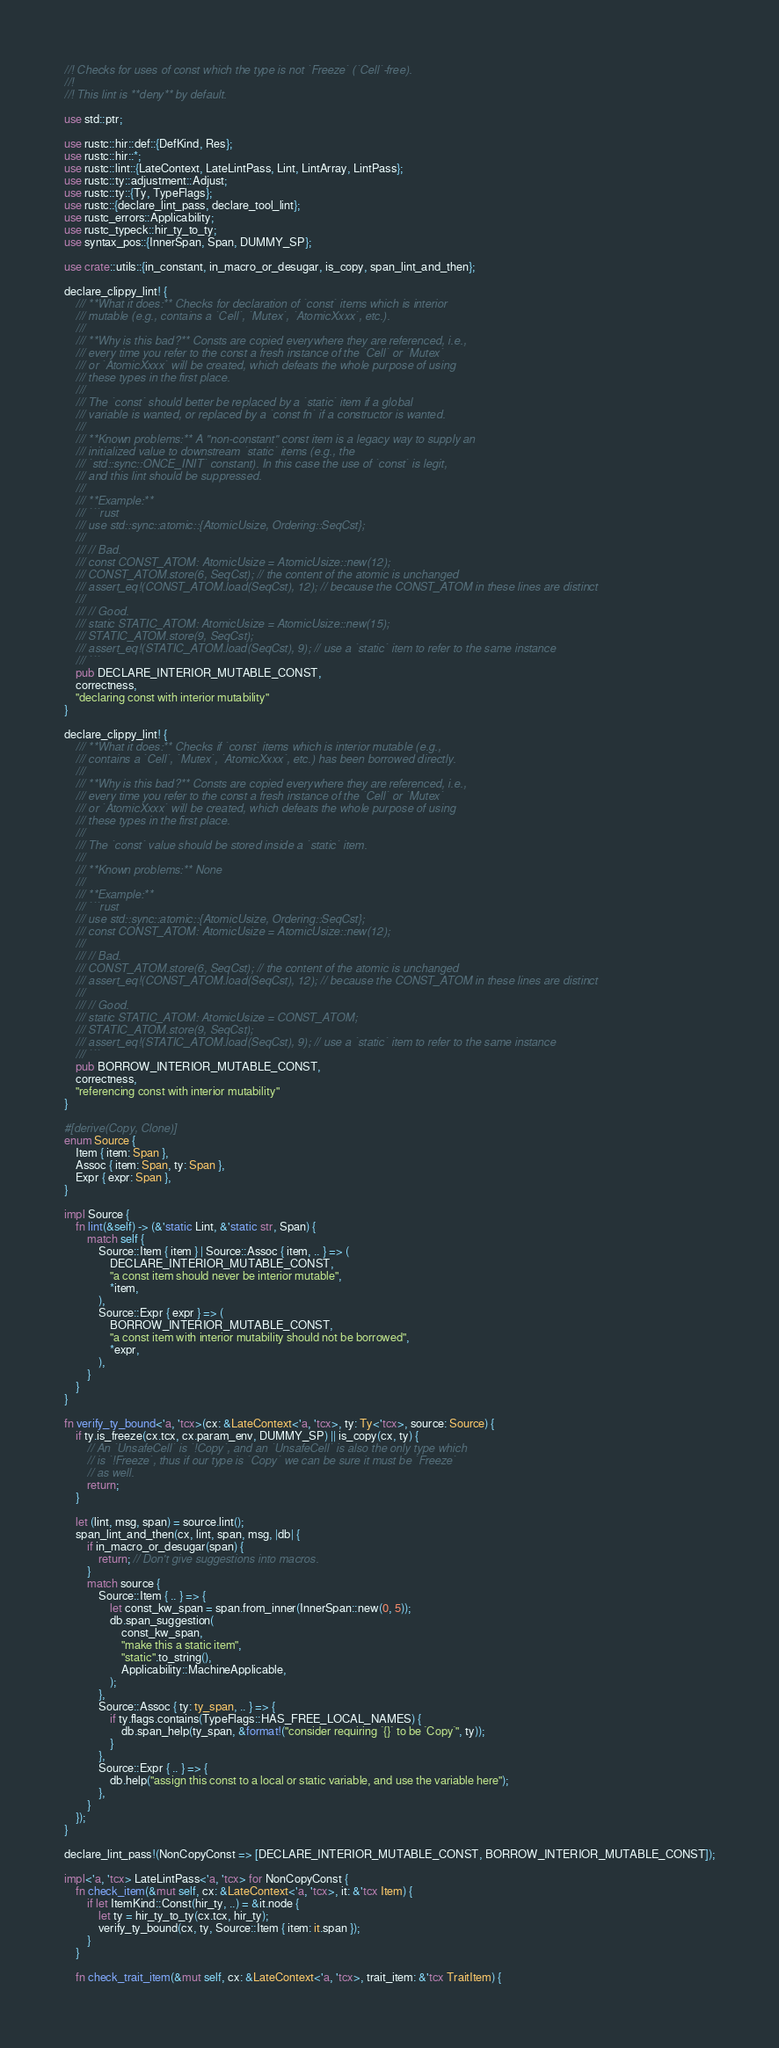Convert code to text. <code><loc_0><loc_0><loc_500><loc_500><_Rust_>//! Checks for uses of const which the type is not `Freeze` (`Cell`-free).
//!
//! This lint is **deny** by default.

use std::ptr;

use rustc::hir::def::{DefKind, Res};
use rustc::hir::*;
use rustc::lint::{LateContext, LateLintPass, Lint, LintArray, LintPass};
use rustc::ty::adjustment::Adjust;
use rustc::ty::{Ty, TypeFlags};
use rustc::{declare_lint_pass, declare_tool_lint};
use rustc_errors::Applicability;
use rustc_typeck::hir_ty_to_ty;
use syntax_pos::{InnerSpan, Span, DUMMY_SP};

use crate::utils::{in_constant, in_macro_or_desugar, is_copy, span_lint_and_then};

declare_clippy_lint! {
    /// **What it does:** Checks for declaration of `const` items which is interior
    /// mutable (e.g., contains a `Cell`, `Mutex`, `AtomicXxxx`, etc.).
    ///
    /// **Why is this bad?** Consts are copied everywhere they are referenced, i.e.,
    /// every time you refer to the const a fresh instance of the `Cell` or `Mutex`
    /// or `AtomicXxxx` will be created, which defeats the whole purpose of using
    /// these types in the first place.
    ///
    /// The `const` should better be replaced by a `static` item if a global
    /// variable is wanted, or replaced by a `const fn` if a constructor is wanted.
    ///
    /// **Known problems:** A "non-constant" const item is a legacy way to supply an
    /// initialized value to downstream `static` items (e.g., the
    /// `std::sync::ONCE_INIT` constant). In this case the use of `const` is legit,
    /// and this lint should be suppressed.
    ///
    /// **Example:**
    /// ```rust
    /// use std::sync::atomic::{AtomicUsize, Ordering::SeqCst};
    ///
    /// // Bad.
    /// const CONST_ATOM: AtomicUsize = AtomicUsize::new(12);
    /// CONST_ATOM.store(6, SeqCst); // the content of the atomic is unchanged
    /// assert_eq!(CONST_ATOM.load(SeqCst), 12); // because the CONST_ATOM in these lines are distinct
    ///
    /// // Good.
    /// static STATIC_ATOM: AtomicUsize = AtomicUsize::new(15);
    /// STATIC_ATOM.store(9, SeqCst);
    /// assert_eq!(STATIC_ATOM.load(SeqCst), 9); // use a `static` item to refer to the same instance
    /// ```
    pub DECLARE_INTERIOR_MUTABLE_CONST,
    correctness,
    "declaring const with interior mutability"
}

declare_clippy_lint! {
    /// **What it does:** Checks if `const` items which is interior mutable (e.g.,
    /// contains a `Cell`, `Mutex`, `AtomicXxxx`, etc.) has been borrowed directly.
    ///
    /// **Why is this bad?** Consts are copied everywhere they are referenced, i.e.,
    /// every time you refer to the const a fresh instance of the `Cell` or `Mutex`
    /// or `AtomicXxxx` will be created, which defeats the whole purpose of using
    /// these types in the first place.
    ///
    /// The `const` value should be stored inside a `static` item.
    ///
    /// **Known problems:** None
    ///
    /// **Example:**
    /// ```rust
    /// use std::sync::atomic::{AtomicUsize, Ordering::SeqCst};
    /// const CONST_ATOM: AtomicUsize = AtomicUsize::new(12);
    ///
    /// // Bad.
    /// CONST_ATOM.store(6, SeqCst); // the content of the atomic is unchanged
    /// assert_eq!(CONST_ATOM.load(SeqCst), 12); // because the CONST_ATOM in these lines are distinct
    ///
    /// // Good.
    /// static STATIC_ATOM: AtomicUsize = CONST_ATOM;
    /// STATIC_ATOM.store(9, SeqCst);
    /// assert_eq!(STATIC_ATOM.load(SeqCst), 9); // use a `static` item to refer to the same instance
    /// ```
    pub BORROW_INTERIOR_MUTABLE_CONST,
    correctness,
    "referencing const with interior mutability"
}

#[derive(Copy, Clone)]
enum Source {
    Item { item: Span },
    Assoc { item: Span, ty: Span },
    Expr { expr: Span },
}

impl Source {
    fn lint(&self) -> (&'static Lint, &'static str, Span) {
        match self {
            Source::Item { item } | Source::Assoc { item, .. } => (
                DECLARE_INTERIOR_MUTABLE_CONST,
                "a const item should never be interior mutable",
                *item,
            ),
            Source::Expr { expr } => (
                BORROW_INTERIOR_MUTABLE_CONST,
                "a const item with interior mutability should not be borrowed",
                *expr,
            ),
        }
    }
}

fn verify_ty_bound<'a, 'tcx>(cx: &LateContext<'a, 'tcx>, ty: Ty<'tcx>, source: Source) {
    if ty.is_freeze(cx.tcx, cx.param_env, DUMMY_SP) || is_copy(cx, ty) {
        // An `UnsafeCell` is `!Copy`, and an `UnsafeCell` is also the only type which
        // is `!Freeze`, thus if our type is `Copy` we can be sure it must be `Freeze`
        // as well.
        return;
    }

    let (lint, msg, span) = source.lint();
    span_lint_and_then(cx, lint, span, msg, |db| {
        if in_macro_or_desugar(span) {
            return; // Don't give suggestions into macros.
        }
        match source {
            Source::Item { .. } => {
                let const_kw_span = span.from_inner(InnerSpan::new(0, 5));
                db.span_suggestion(
                    const_kw_span,
                    "make this a static item",
                    "static".to_string(),
                    Applicability::MachineApplicable,
                );
            },
            Source::Assoc { ty: ty_span, .. } => {
                if ty.flags.contains(TypeFlags::HAS_FREE_LOCAL_NAMES) {
                    db.span_help(ty_span, &format!("consider requiring `{}` to be `Copy`", ty));
                }
            },
            Source::Expr { .. } => {
                db.help("assign this const to a local or static variable, and use the variable here");
            },
        }
    });
}

declare_lint_pass!(NonCopyConst => [DECLARE_INTERIOR_MUTABLE_CONST, BORROW_INTERIOR_MUTABLE_CONST]);

impl<'a, 'tcx> LateLintPass<'a, 'tcx> for NonCopyConst {
    fn check_item(&mut self, cx: &LateContext<'a, 'tcx>, it: &'tcx Item) {
        if let ItemKind::Const(hir_ty, ..) = &it.node {
            let ty = hir_ty_to_ty(cx.tcx, hir_ty);
            verify_ty_bound(cx, ty, Source::Item { item: it.span });
        }
    }

    fn check_trait_item(&mut self, cx: &LateContext<'a, 'tcx>, trait_item: &'tcx TraitItem) {</code> 